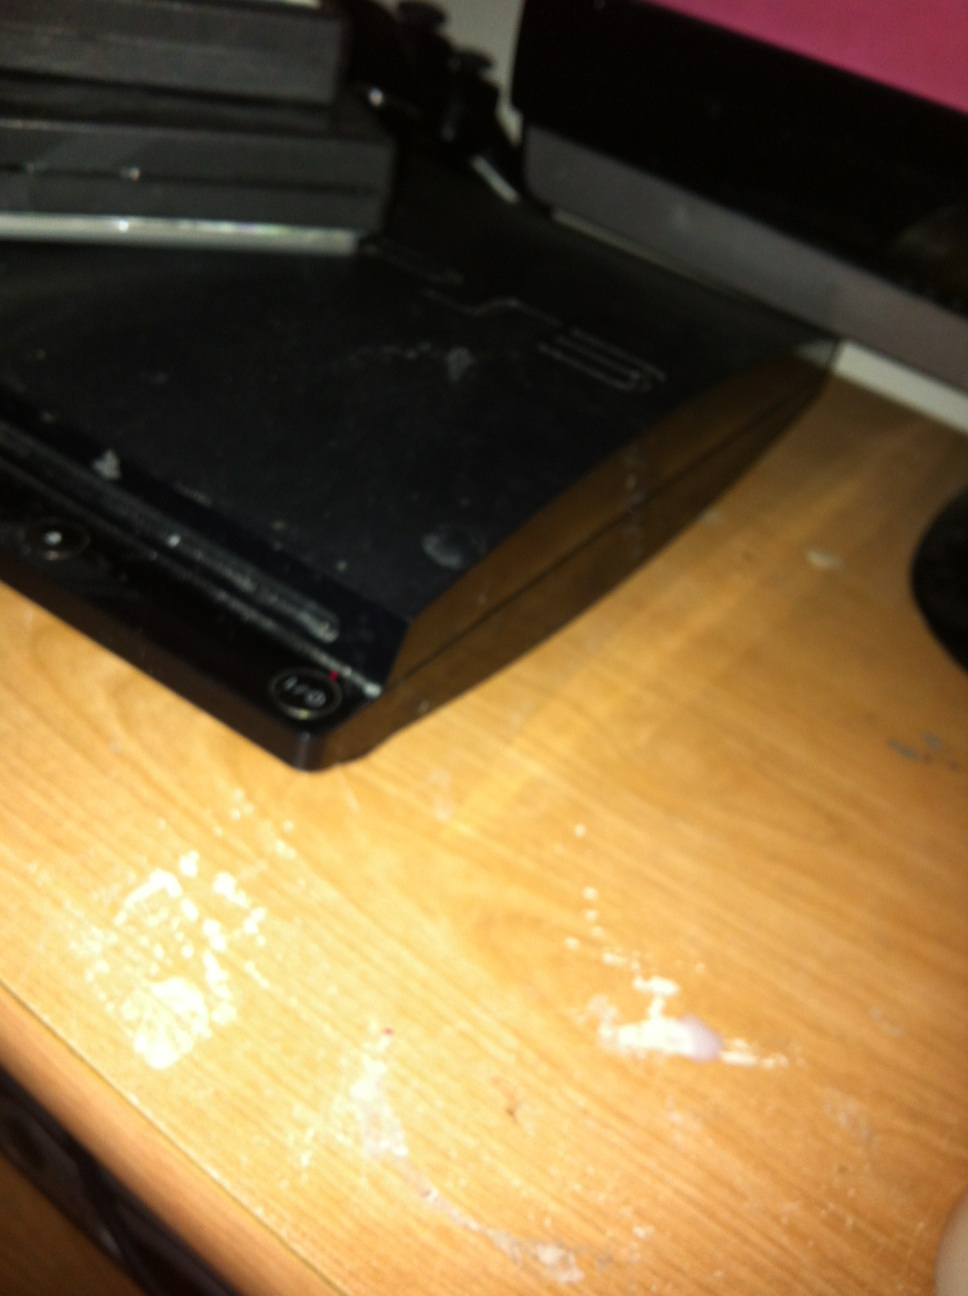Imagine what the PlayStation 3 would be like if it was a living, sentient being. If the PlayStation 3 were a living, sentient being, imagine it as a digital wizard, cloaked in shimmering metallic robes, with circuits and wires intricately woven into its fabric. It would have a glowing, holographic face that changes colors based on its mood—blue for calm, red for excited, and green for curious. This intelligent entity would be a master storyteller, conjuring vivid, immersive worlds with a flick of its hand, inviting players to journey through epic adventures. It would have an encyclopedic knowledge of gaming lore and a playful, competitive spirit, always eager to engage in friendly challenges. Its voice, echoing with digital resonance, would guide players with wisdom and encouragement. As a guardian of fun and creativity, this sentient PlayStation 3 would foster a community of gamers, sharing in the joy of exploration and the thrill of discovery, all while evolving and learning from each new experience. 